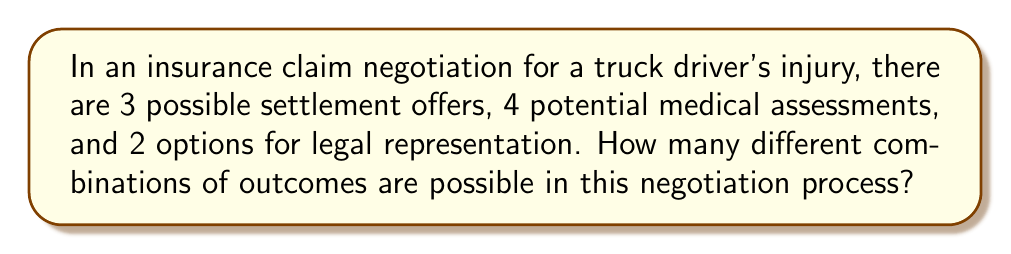Could you help me with this problem? Let's break this down step-by-step:

1) We have three independent factors that can vary:
   - Settlement offers: 3 options
   - Medical assessments: 4 options
   - Legal representation: 2 options

2) To find the total number of possible combinations, we use the multiplication principle of counting. This principle states that if we have $m$ ways of doing something, $n$ ways of doing another thing, and $p$ ways of doing a third thing, then there are $m \times n \times p$ ways to do all three things.

3) In this case:
   $$ \text{Total combinations} = \text{Settlement options} \times \text{Medical assessments} \times \text{Legal representation options} $$

4) Substituting the numbers:
   $$ \text{Total combinations} = 3 \times 4 \times 2 $$

5) Calculating:
   $$ \text{Total combinations} = 24 $$

Therefore, there are 24 different possible combinations of outcomes in this negotiation process.
Answer: 24 